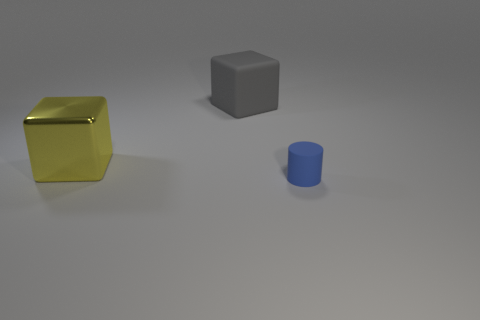Add 1 small blue cylinders. How many objects exist? 4 Subtract all cylinders. How many objects are left? 2 Add 1 small brown shiny blocks. How many small brown shiny blocks exist? 1 Subtract 0 green cubes. How many objects are left? 3 Subtract all gray things. Subtract all blue matte things. How many objects are left? 1 Add 3 blue cylinders. How many blue cylinders are left? 4 